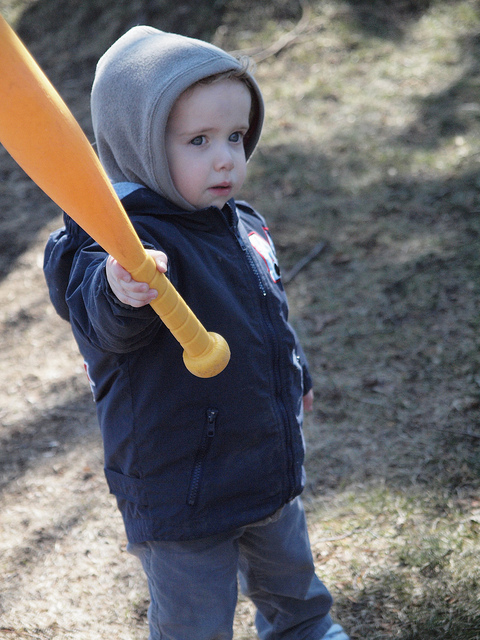<image>What metal is the bat made out of? The bat is not made out of metal. It is made out of plastic. What metal is the bat made out of? The bat is not made out of plastic. 